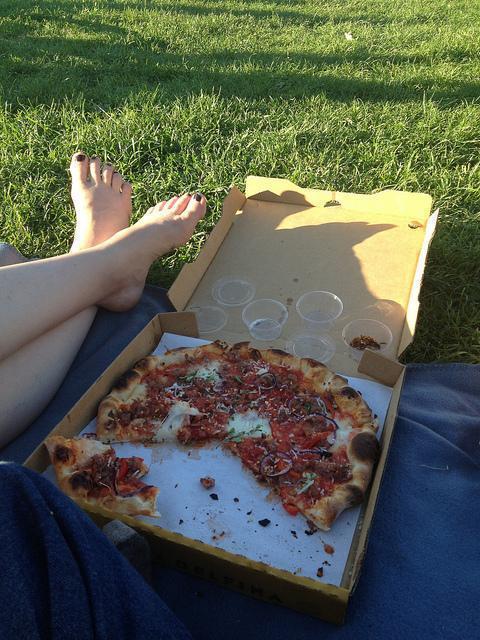What is the proper name for this style of eating?
Select the accurate answer and provide explanation: 'Answer: answer
Rationale: rationale.'
Options: Picnic, brunch, party, soiree. Answer: picnic.
Rationale: They are having a picnic. 